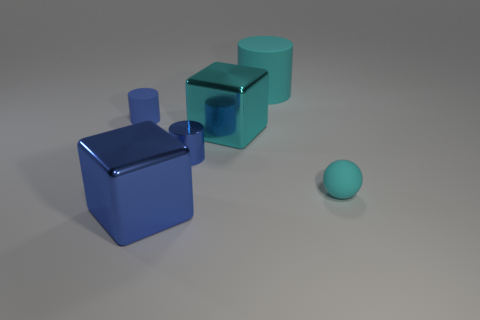Add 2 large cyan rubber cylinders. How many objects exist? 8 Subtract all spheres. How many objects are left? 5 Add 1 big blocks. How many big blocks exist? 3 Subtract 0 gray balls. How many objects are left? 6 Subtract all metal things. Subtract all cyan metal blocks. How many objects are left? 2 Add 3 small blue shiny objects. How many small blue shiny objects are left? 4 